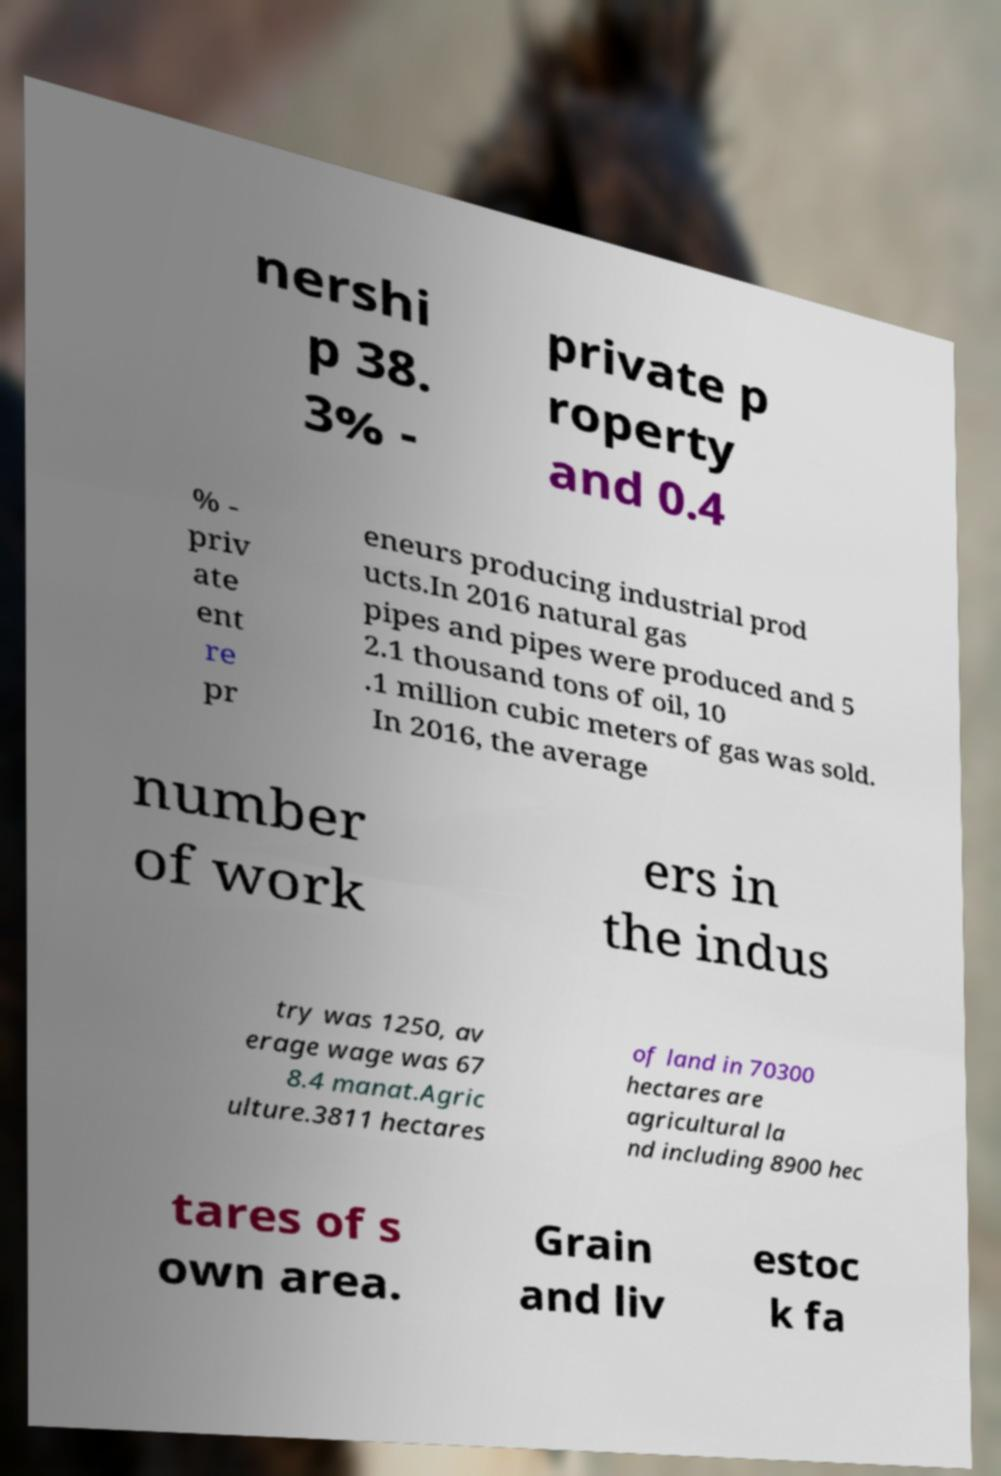Can you read and provide the text displayed in the image?This photo seems to have some interesting text. Can you extract and type it out for me? nershi p 38. 3% - private p roperty and 0.4 % - priv ate ent re pr eneurs producing industrial prod ucts.In 2016 natural gas pipes and pipes were produced and 5 2.1 thousand tons of oil, 10 .1 million cubic meters of gas was sold. In 2016, the average number of work ers in the indus try was 1250, av erage wage was 67 8.4 manat.Agric ulture.3811 hectares of land in 70300 hectares are agricultural la nd including 8900 hec tares of s own area. Grain and liv estoc k fa 